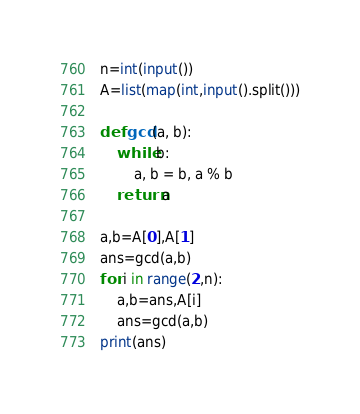<code> <loc_0><loc_0><loc_500><loc_500><_Python_>n=int(input())
A=list(map(int,input().split()))

def gcd(a, b):
    while b:
        a, b = b, a % b
    return a

a,b=A[0],A[1]
ans=gcd(a,b)
for i in range(2,n):
    a,b=ans,A[i]
    ans=gcd(a,b)
print(ans)</code> 